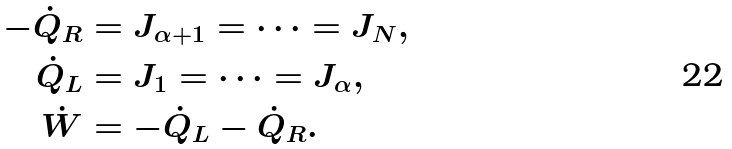Convert formula to latex. <formula><loc_0><loc_0><loc_500><loc_500>- \dot { Q } _ { R } & = J _ { \alpha + 1 } = \cdots = J _ { N } , \\ \dot { Q } _ { L } & = J _ { 1 } = \cdots = J _ { \alpha } , \\ \dot { W } & = - \dot { Q } _ { L } - \dot { Q } _ { R } .</formula> 